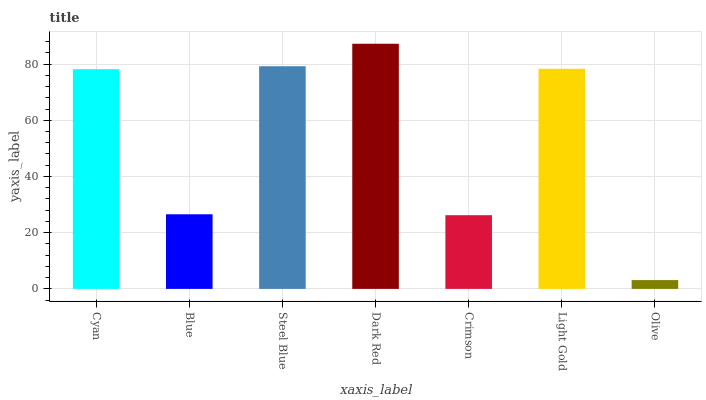Is Olive the minimum?
Answer yes or no. Yes. Is Dark Red the maximum?
Answer yes or no. Yes. Is Blue the minimum?
Answer yes or no. No. Is Blue the maximum?
Answer yes or no. No. Is Cyan greater than Blue?
Answer yes or no. Yes. Is Blue less than Cyan?
Answer yes or no. Yes. Is Blue greater than Cyan?
Answer yes or no. No. Is Cyan less than Blue?
Answer yes or no. No. Is Cyan the high median?
Answer yes or no. Yes. Is Cyan the low median?
Answer yes or no. Yes. Is Steel Blue the high median?
Answer yes or no. No. Is Light Gold the low median?
Answer yes or no. No. 